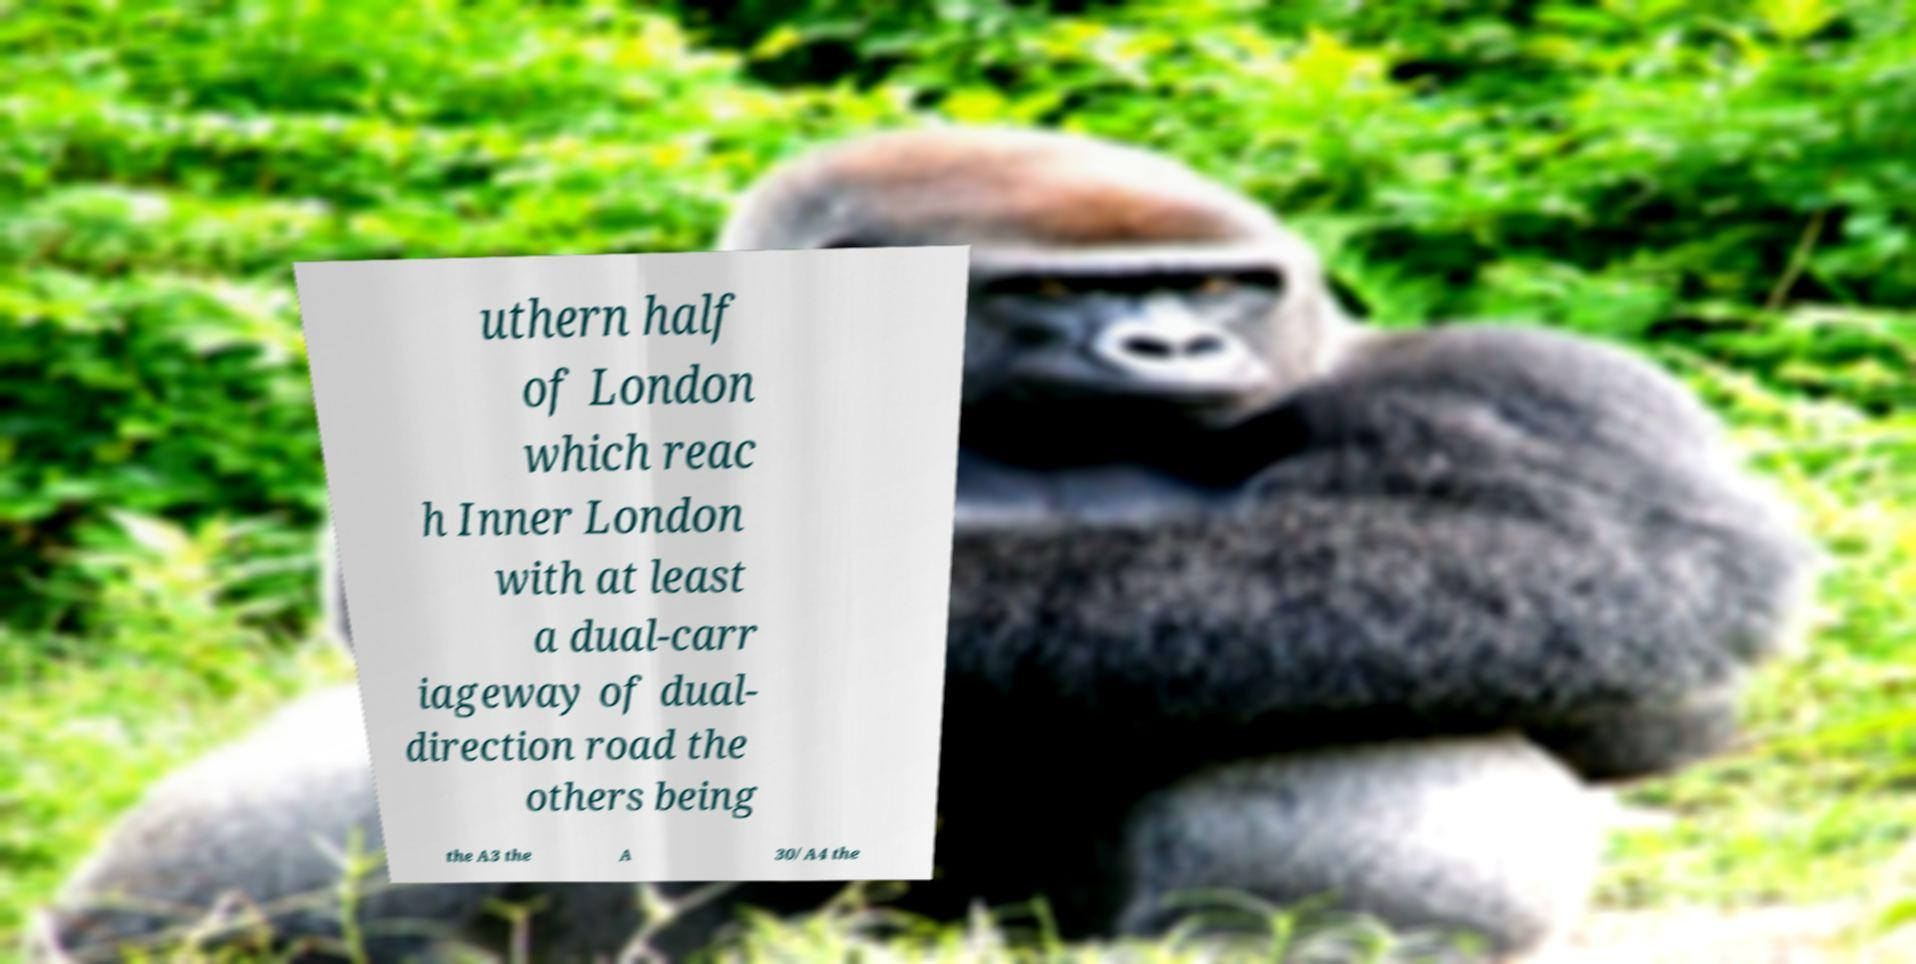I need the written content from this picture converted into text. Can you do that? uthern half of London which reac h Inner London with at least a dual-carr iageway of dual- direction road the others being the A3 the A 30/A4 the 